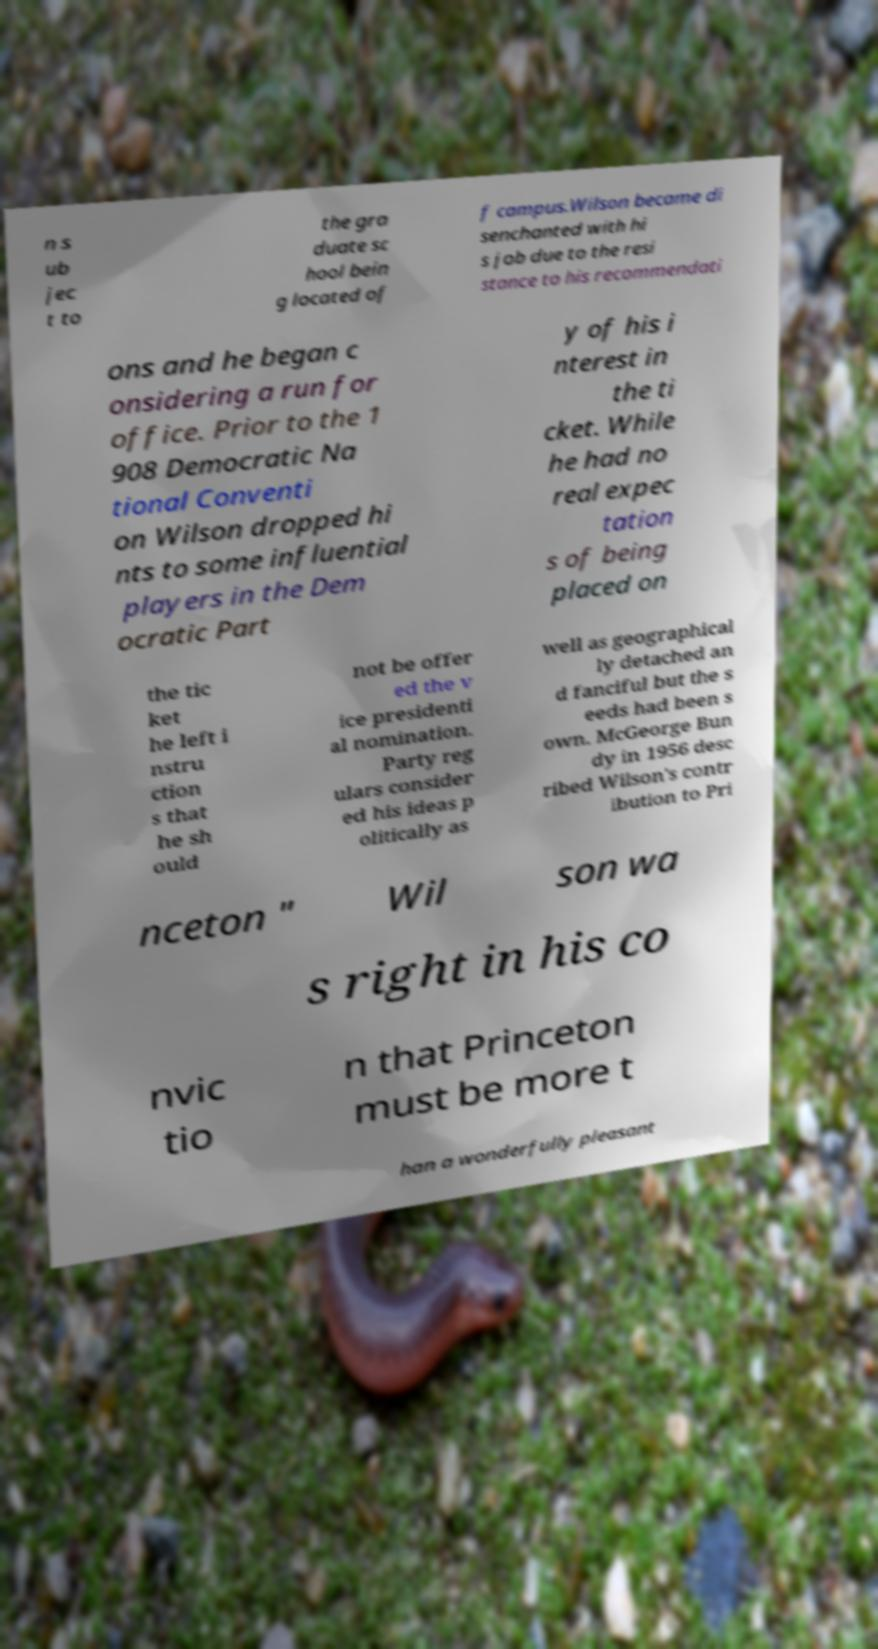Can you read and provide the text displayed in the image?This photo seems to have some interesting text. Can you extract and type it out for me? n s ub jec t to the gra duate sc hool bein g located of f campus.Wilson became di senchanted with hi s job due to the resi stance to his recommendati ons and he began c onsidering a run for office. Prior to the 1 908 Democratic Na tional Conventi on Wilson dropped hi nts to some influential players in the Dem ocratic Part y of his i nterest in the ti cket. While he had no real expec tation s of being placed on the tic ket he left i nstru ction s that he sh ould not be offer ed the v ice presidenti al nomination. Party reg ulars consider ed his ideas p olitically as well as geographical ly detached an d fanciful but the s eeds had been s own. McGeorge Bun dy in 1956 desc ribed Wilson's contr ibution to Pri nceton " Wil son wa s right in his co nvic tio n that Princeton must be more t han a wonderfully pleasant 